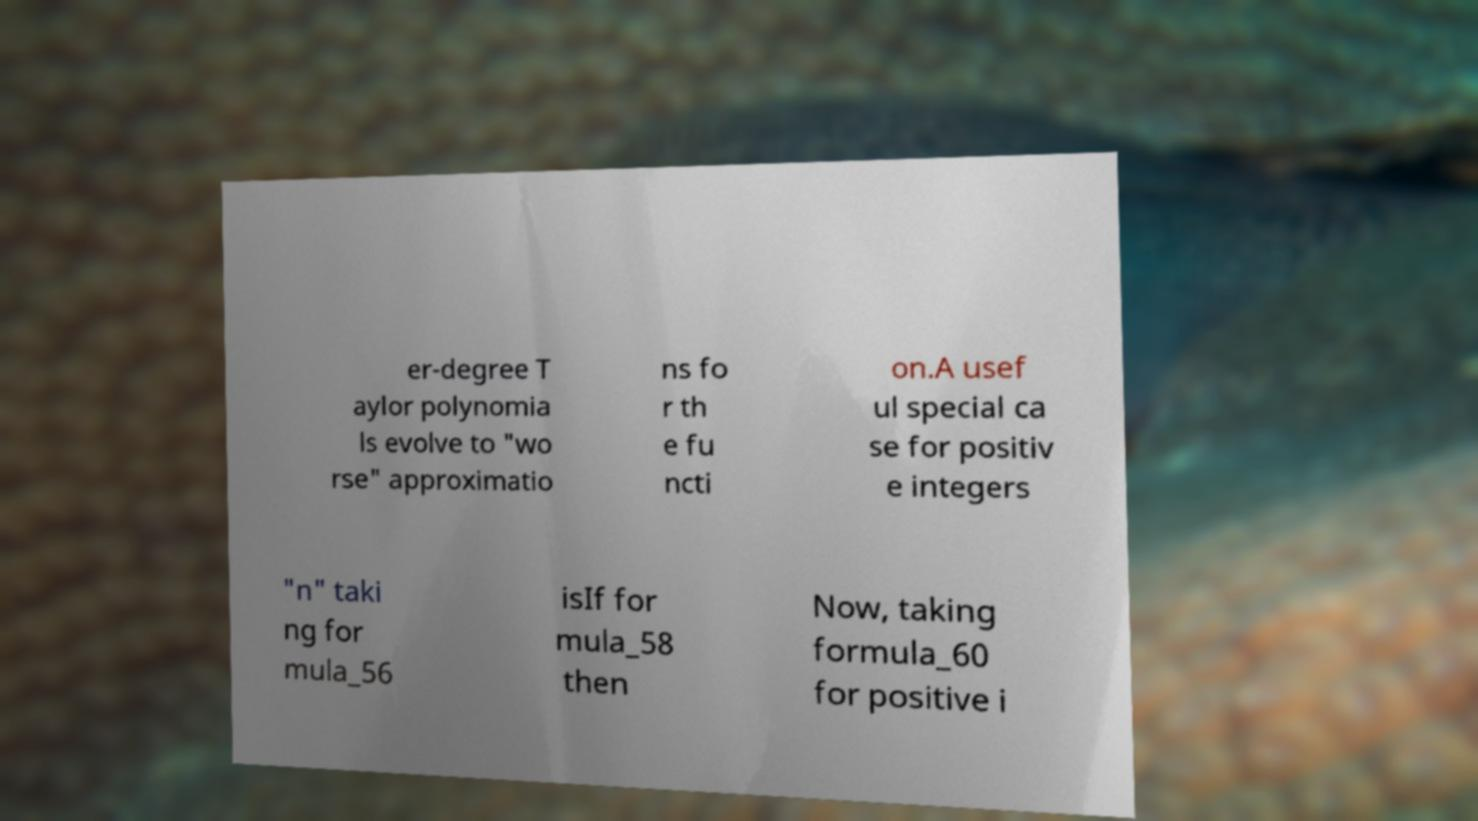Please identify and transcribe the text found in this image. er-degree T aylor polynomia ls evolve to "wo rse" approximatio ns fo r th e fu ncti on.A usef ul special ca se for positiv e integers "n" taki ng for mula_56 isIf for mula_58 then Now, taking formula_60 for positive i 